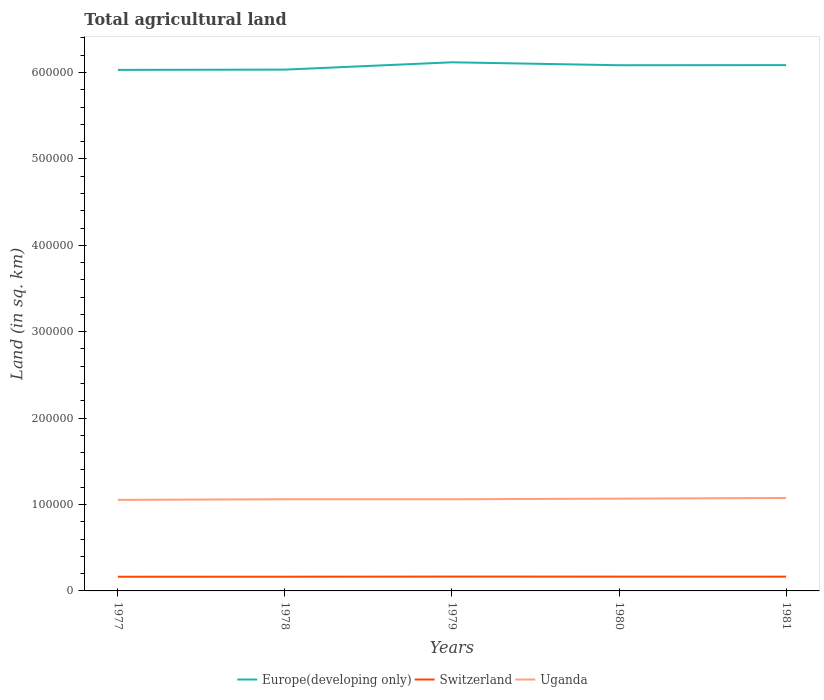Does the line corresponding to Switzerland intersect with the line corresponding to Uganda?
Make the answer very short. No. Is the number of lines equal to the number of legend labels?
Make the answer very short. Yes. Across all years, what is the maximum total agricultural land in Uganda?
Your answer should be compact. 1.05e+05. In which year was the total agricultural land in Europe(developing only) maximum?
Provide a succinct answer. 1977. What is the total total agricultural land in Uganda in the graph?
Provide a succinct answer. -2220. What is the difference between the highest and the second highest total agricultural land in Europe(developing only)?
Give a very brief answer. 8780. Is the total agricultural land in Uganda strictly greater than the total agricultural land in Europe(developing only) over the years?
Provide a succinct answer. Yes. How many years are there in the graph?
Provide a succinct answer. 5. Where does the legend appear in the graph?
Your answer should be compact. Bottom center. What is the title of the graph?
Give a very brief answer. Total agricultural land. What is the label or title of the Y-axis?
Provide a succinct answer. Land (in sq. km). What is the Land (in sq. km) of Europe(developing only) in 1977?
Keep it short and to the point. 6.03e+05. What is the Land (in sq. km) of Switzerland in 1977?
Your response must be concise. 1.64e+04. What is the Land (in sq. km) in Uganda in 1977?
Your response must be concise. 1.05e+05. What is the Land (in sq. km) in Europe(developing only) in 1978?
Your answer should be very brief. 6.03e+05. What is the Land (in sq. km) in Switzerland in 1978?
Your response must be concise. 1.64e+04. What is the Land (in sq. km) in Uganda in 1978?
Make the answer very short. 1.06e+05. What is the Land (in sq. km) in Europe(developing only) in 1979?
Your answer should be very brief. 6.12e+05. What is the Land (in sq. km) in Switzerland in 1979?
Your response must be concise. 1.66e+04. What is the Land (in sq. km) of Uganda in 1979?
Ensure brevity in your answer.  1.06e+05. What is the Land (in sq. km) of Europe(developing only) in 1980?
Make the answer very short. 6.08e+05. What is the Land (in sq. km) of Switzerland in 1980?
Provide a succinct answer. 1.65e+04. What is the Land (in sq. km) of Uganda in 1980?
Your response must be concise. 1.07e+05. What is the Land (in sq. km) of Europe(developing only) in 1981?
Your answer should be compact. 6.09e+05. What is the Land (in sq. km) in Switzerland in 1981?
Offer a very short reply. 1.65e+04. What is the Land (in sq. km) of Uganda in 1981?
Keep it short and to the point. 1.08e+05. Across all years, what is the maximum Land (in sq. km) of Europe(developing only)?
Offer a very short reply. 6.12e+05. Across all years, what is the maximum Land (in sq. km) in Switzerland?
Make the answer very short. 1.66e+04. Across all years, what is the maximum Land (in sq. km) in Uganda?
Provide a succinct answer. 1.08e+05. Across all years, what is the minimum Land (in sq. km) in Europe(developing only)?
Ensure brevity in your answer.  6.03e+05. Across all years, what is the minimum Land (in sq. km) of Switzerland?
Your answer should be very brief. 1.64e+04. Across all years, what is the minimum Land (in sq. km) of Uganda?
Give a very brief answer. 1.05e+05. What is the total Land (in sq. km) of Europe(developing only) in the graph?
Give a very brief answer. 3.04e+06. What is the total Land (in sq. km) of Switzerland in the graph?
Offer a terse response. 8.25e+04. What is the total Land (in sq. km) of Uganda in the graph?
Make the answer very short. 5.32e+05. What is the difference between the Land (in sq. km) in Europe(developing only) in 1977 and that in 1978?
Provide a succinct answer. -310. What is the difference between the Land (in sq. km) in Switzerland in 1977 and that in 1978?
Keep it short and to the point. -35. What is the difference between the Land (in sq. km) of Uganda in 1977 and that in 1978?
Provide a short and direct response. -720. What is the difference between the Land (in sq. km) of Europe(developing only) in 1977 and that in 1979?
Ensure brevity in your answer.  -8780. What is the difference between the Land (in sq. km) of Switzerland in 1977 and that in 1979?
Provide a succinct answer. -173. What is the difference between the Land (in sq. km) of Uganda in 1977 and that in 1979?
Make the answer very short. -720. What is the difference between the Land (in sq. km) in Europe(developing only) in 1977 and that in 1980?
Ensure brevity in your answer.  -5380. What is the difference between the Land (in sq. km) in Switzerland in 1977 and that in 1980?
Give a very brief answer. -125. What is the difference between the Land (in sq. km) of Uganda in 1977 and that in 1980?
Your answer should be compact. -1420. What is the difference between the Land (in sq. km) of Europe(developing only) in 1977 and that in 1981?
Ensure brevity in your answer.  -5520. What is the difference between the Land (in sq. km) in Switzerland in 1977 and that in 1981?
Make the answer very short. -76. What is the difference between the Land (in sq. km) of Uganda in 1977 and that in 1981?
Your answer should be very brief. -2220. What is the difference between the Land (in sq. km) of Europe(developing only) in 1978 and that in 1979?
Keep it short and to the point. -8470. What is the difference between the Land (in sq. km) of Switzerland in 1978 and that in 1979?
Your answer should be compact. -138. What is the difference between the Land (in sq. km) of Europe(developing only) in 1978 and that in 1980?
Your answer should be compact. -5070. What is the difference between the Land (in sq. km) of Switzerland in 1978 and that in 1980?
Your answer should be very brief. -90. What is the difference between the Land (in sq. km) in Uganda in 1978 and that in 1980?
Your answer should be compact. -700. What is the difference between the Land (in sq. km) of Europe(developing only) in 1978 and that in 1981?
Keep it short and to the point. -5210. What is the difference between the Land (in sq. km) of Switzerland in 1978 and that in 1981?
Your response must be concise. -41. What is the difference between the Land (in sq. km) in Uganda in 1978 and that in 1981?
Offer a terse response. -1500. What is the difference between the Land (in sq. km) in Europe(developing only) in 1979 and that in 1980?
Offer a terse response. 3400. What is the difference between the Land (in sq. km) in Switzerland in 1979 and that in 1980?
Offer a very short reply. 48. What is the difference between the Land (in sq. km) in Uganda in 1979 and that in 1980?
Ensure brevity in your answer.  -700. What is the difference between the Land (in sq. km) in Europe(developing only) in 1979 and that in 1981?
Offer a terse response. 3260. What is the difference between the Land (in sq. km) in Switzerland in 1979 and that in 1981?
Provide a succinct answer. 97. What is the difference between the Land (in sq. km) in Uganda in 1979 and that in 1981?
Offer a very short reply. -1500. What is the difference between the Land (in sq. km) in Europe(developing only) in 1980 and that in 1981?
Offer a terse response. -140. What is the difference between the Land (in sq. km) in Uganda in 1980 and that in 1981?
Make the answer very short. -800. What is the difference between the Land (in sq. km) of Europe(developing only) in 1977 and the Land (in sq. km) of Switzerland in 1978?
Your answer should be compact. 5.87e+05. What is the difference between the Land (in sq. km) of Europe(developing only) in 1977 and the Land (in sq. km) of Uganda in 1978?
Ensure brevity in your answer.  4.97e+05. What is the difference between the Land (in sq. km) in Switzerland in 1977 and the Land (in sq. km) in Uganda in 1978?
Offer a very short reply. -8.97e+04. What is the difference between the Land (in sq. km) in Europe(developing only) in 1977 and the Land (in sq. km) in Switzerland in 1979?
Ensure brevity in your answer.  5.86e+05. What is the difference between the Land (in sq. km) in Europe(developing only) in 1977 and the Land (in sq. km) in Uganda in 1979?
Offer a very short reply. 4.97e+05. What is the difference between the Land (in sq. km) of Switzerland in 1977 and the Land (in sq. km) of Uganda in 1979?
Your response must be concise. -8.97e+04. What is the difference between the Land (in sq. km) in Europe(developing only) in 1977 and the Land (in sq. km) in Switzerland in 1980?
Ensure brevity in your answer.  5.87e+05. What is the difference between the Land (in sq. km) in Europe(developing only) in 1977 and the Land (in sq. km) in Uganda in 1980?
Offer a terse response. 4.96e+05. What is the difference between the Land (in sq. km) of Switzerland in 1977 and the Land (in sq. km) of Uganda in 1980?
Make the answer very short. -9.04e+04. What is the difference between the Land (in sq. km) of Europe(developing only) in 1977 and the Land (in sq. km) of Switzerland in 1981?
Make the answer very short. 5.87e+05. What is the difference between the Land (in sq. km) in Europe(developing only) in 1977 and the Land (in sq. km) in Uganda in 1981?
Make the answer very short. 4.95e+05. What is the difference between the Land (in sq. km) of Switzerland in 1977 and the Land (in sq. km) of Uganda in 1981?
Provide a succinct answer. -9.12e+04. What is the difference between the Land (in sq. km) in Europe(developing only) in 1978 and the Land (in sq. km) in Switzerland in 1979?
Provide a succinct answer. 5.87e+05. What is the difference between the Land (in sq. km) of Europe(developing only) in 1978 and the Land (in sq. km) of Uganda in 1979?
Keep it short and to the point. 4.97e+05. What is the difference between the Land (in sq. km) in Switzerland in 1978 and the Land (in sq. km) in Uganda in 1979?
Offer a very short reply. -8.97e+04. What is the difference between the Land (in sq. km) in Europe(developing only) in 1978 and the Land (in sq. km) in Switzerland in 1980?
Your answer should be very brief. 5.87e+05. What is the difference between the Land (in sq. km) in Europe(developing only) in 1978 and the Land (in sq. km) in Uganda in 1980?
Your response must be concise. 4.97e+05. What is the difference between the Land (in sq. km) in Switzerland in 1978 and the Land (in sq. km) in Uganda in 1980?
Offer a terse response. -9.04e+04. What is the difference between the Land (in sq. km) of Europe(developing only) in 1978 and the Land (in sq. km) of Switzerland in 1981?
Ensure brevity in your answer.  5.87e+05. What is the difference between the Land (in sq. km) in Europe(developing only) in 1978 and the Land (in sq. km) in Uganda in 1981?
Keep it short and to the point. 4.96e+05. What is the difference between the Land (in sq. km) of Switzerland in 1978 and the Land (in sq. km) of Uganda in 1981?
Your answer should be compact. -9.12e+04. What is the difference between the Land (in sq. km) in Europe(developing only) in 1979 and the Land (in sq. km) in Switzerland in 1980?
Your answer should be compact. 5.95e+05. What is the difference between the Land (in sq. km) in Europe(developing only) in 1979 and the Land (in sq. km) in Uganda in 1980?
Your answer should be compact. 5.05e+05. What is the difference between the Land (in sq. km) of Switzerland in 1979 and the Land (in sq. km) of Uganda in 1980?
Your answer should be very brief. -9.02e+04. What is the difference between the Land (in sq. km) in Europe(developing only) in 1979 and the Land (in sq. km) in Switzerland in 1981?
Your answer should be very brief. 5.95e+05. What is the difference between the Land (in sq. km) of Europe(developing only) in 1979 and the Land (in sq. km) of Uganda in 1981?
Your answer should be very brief. 5.04e+05. What is the difference between the Land (in sq. km) in Switzerland in 1979 and the Land (in sq. km) in Uganda in 1981?
Give a very brief answer. -9.10e+04. What is the difference between the Land (in sq. km) of Europe(developing only) in 1980 and the Land (in sq. km) of Switzerland in 1981?
Give a very brief answer. 5.92e+05. What is the difference between the Land (in sq. km) of Europe(developing only) in 1980 and the Land (in sq. km) of Uganda in 1981?
Provide a short and direct response. 5.01e+05. What is the difference between the Land (in sq. km) in Switzerland in 1980 and the Land (in sq. km) in Uganda in 1981?
Your response must be concise. -9.11e+04. What is the average Land (in sq. km) of Europe(developing only) per year?
Keep it short and to the point. 6.07e+05. What is the average Land (in sq. km) of Switzerland per year?
Offer a terse response. 1.65e+04. What is the average Land (in sq. km) of Uganda per year?
Your answer should be compact. 1.06e+05. In the year 1977, what is the difference between the Land (in sq. km) in Europe(developing only) and Land (in sq. km) in Switzerland?
Provide a succinct answer. 5.87e+05. In the year 1977, what is the difference between the Land (in sq. km) of Europe(developing only) and Land (in sq. km) of Uganda?
Offer a terse response. 4.98e+05. In the year 1977, what is the difference between the Land (in sq. km) of Switzerland and Land (in sq. km) of Uganda?
Provide a succinct answer. -8.90e+04. In the year 1978, what is the difference between the Land (in sq. km) in Europe(developing only) and Land (in sq. km) in Switzerland?
Your answer should be compact. 5.87e+05. In the year 1978, what is the difference between the Land (in sq. km) in Europe(developing only) and Land (in sq. km) in Uganda?
Your response must be concise. 4.97e+05. In the year 1978, what is the difference between the Land (in sq. km) of Switzerland and Land (in sq. km) of Uganda?
Offer a terse response. -8.97e+04. In the year 1979, what is the difference between the Land (in sq. km) of Europe(developing only) and Land (in sq. km) of Switzerland?
Ensure brevity in your answer.  5.95e+05. In the year 1979, what is the difference between the Land (in sq. km) in Europe(developing only) and Land (in sq. km) in Uganda?
Give a very brief answer. 5.06e+05. In the year 1979, what is the difference between the Land (in sq. km) in Switzerland and Land (in sq. km) in Uganda?
Provide a succinct answer. -8.95e+04. In the year 1980, what is the difference between the Land (in sq. km) in Europe(developing only) and Land (in sq. km) in Switzerland?
Offer a very short reply. 5.92e+05. In the year 1980, what is the difference between the Land (in sq. km) in Europe(developing only) and Land (in sq. km) in Uganda?
Offer a very short reply. 5.02e+05. In the year 1980, what is the difference between the Land (in sq. km) of Switzerland and Land (in sq. km) of Uganda?
Offer a very short reply. -9.03e+04. In the year 1981, what is the difference between the Land (in sq. km) in Europe(developing only) and Land (in sq. km) in Switzerland?
Your answer should be compact. 5.92e+05. In the year 1981, what is the difference between the Land (in sq. km) of Europe(developing only) and Land (in sq. km) of Uganda?
Ensure brevity in your answer.  5.01e+05. In the year 1981, what is the difference between the Land (in sq. km) in Switzerland and Land (in sq. km) in Uganda?
Provide a succinct answer. -9.11e+04. What is the ratio of the Land (in sq. km) of Switzerland in 1977 to that in 1978?
Make the answer very short. 1. What is the ratio of the Land (in sq. km) in Uganda in 1977 to that in 1978?
Ensure brevity in your answer.  0.99. What is the ratio of the Land (in sq. km) in Europe(developing only) in 1977 to that in 1979?
Your answer should be very brief. 0.99. What is the ratio of the Land (in sq. km) in Switzerland in 1977 to that in 1979?
Offer a terse response. 0.99. What is the ratio of the Land (in sq. km) of Europe(developing only) in 1977 to that in 1980?
Offer a terse response. 0.99. What is the ratio of the Land (in sq. km) in Uganda in 1977 to that in 1980?
Keep it short and to the point. 0.99. What is the ratio of the Land (in sq. km) of Europe(developing only) in 1977 to that in 1981?
Give a very brief answer. 0.99. What is the ratio of the Land (in sq. km) of Uganda in 1977 to that in 1981?
Provide a succinct answer. 0.98. What is the ratio of the Land (in sq. km) of Europe(developing only) in 1978 to that in 1979?
Keep it short and to the point. 0.99. What is the ratio of the Land (in sq. km) in Switzerland in 1978 to that in 1979?
Your answer should be compact. 0.99. What is the ratio of the Land (in sq. km) of Uganda in 1978 to that in 1979?
Ensure brevity in your answer.  1. What is the ratio of the Land (in sq. km) of Switzerland in 1978 to that in 1980?
Provide a short and direct response. 0.99. What is the ratio of the Land (in sq. km) of Uganda in 1978 to that in 1980?
Provide a short and direct response. 0.99. What is the ratio of the Land (in sq. km) of Uganda in 1978 to that in 1981?
Offer a very short reply. 0.99. What is the ratio of the Land (in sq. km) in Europe(developing only) in 1979 to that in 1980?
Give a very brief answer. 1.01. What is the ratio of the Land (in sq. km) in Uganda in 1979 to that in 1980?
Your response must be concise. 0.99. What is the ratio of the Land (in sq. km) of Europe(developing only) in 1979 to that in 1981?
Ensure brevity in your answer.  1.01. What is the ratio of the Land (in sq. km) of Switzerland in 1979 to that in 1981?
Provide a short and direct response. 1.01. What is the ratio of the Land (in sq. km) in Uganda in 1979 to that in 1981?
Keep it short and to the point. 0.99. What is the ratio of the Land (in sq. km) of Switzerland in 1980 to that in 1981?
Ensure brevity in your answer.  1. What is the ratio of the Land (in sq. km) in Uganda in 1980 to that in 1981?
Provide a succinct answer. 0.99. What is the difference between the highest and the second highest Land (in sq. km) of Europe(developing only)?
Provide a short and direct response. 3260. What is the difference between the highest and the second highest Land (in sq. km) of Switzerland?
Your answer should be very brief. 48. What is the difference between the highest and the second highest Land (in sq. km) in Uganda?
Make the answer very short. 800. What is the difference between the highest and the lowest Land (in sq. km) of Europe(developing only)?
Make the answer very short. 8780. What is the difference between the highest and the lowest Land (in sq. km) in Switzerland?
Give a very brief answer. 173. What is the difference between the highest and the lowest Land (in sq. km) in Uganda?
Your response must be concise. 2220. 